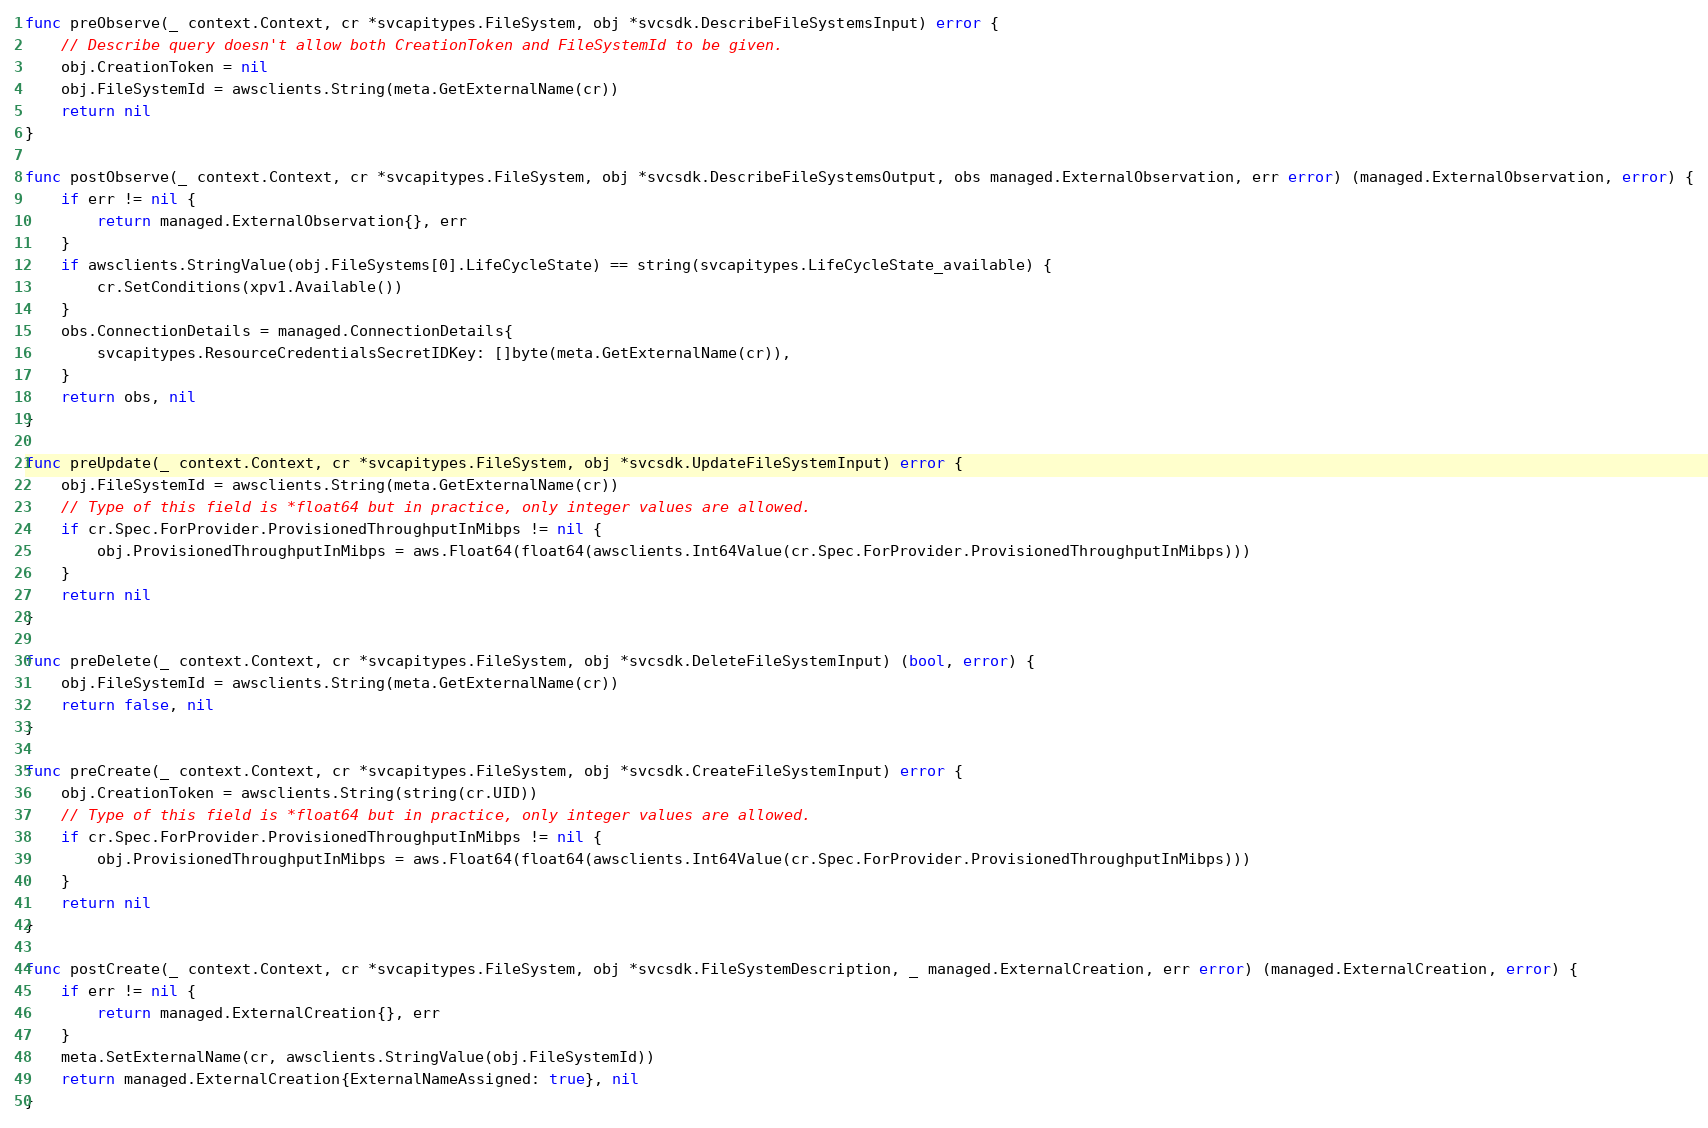Convert code to text. <code><loc_0><loc_0><loc_500><loc_500><_Go_>func preObserve(_ context.Context, cr *svcapitypes.FileSystem, obj *svcsdk.DescribeFileSystemsInput) error {
	// Describe query doesn't allow both CreationToken and FileSystemId to be given.
	obj.CreationToken = nil
	obj.FileSystemId = awsclients.String(meta.GetExternalName(cr))
	return nil
}

func postObserve(_ context.Context, cr *svcapitypes.FileSystem, obj *svcsdk.DescribeFileSystemsOutput, obs managed.ExternalObservation, err error) (managed.ExternalObservation, error) {
	if err != nil {
		return managed.ExternalObservation{}, err
	}
	if awsclients.StringValue(obj.FileSystems[0].LifeCycleState) == string(svcapitypes.LifeCycleState_available) {
		cr.SetConditions(xpv1.Available())
	}
	obs.ConnectionDetails = managed.ConnectionDetails{
		svcapitypes.ResourceCredentialsSecretIDKey: []byte(meta.GetExternalName(cr)),
	}
	return obs, nil
}

func preUpdate(_ context.Context, cr *svcapitypes.FileSystem, obj *svcsdk.UpdateFileSystemInput) error {
	obj.FileSystemId = awsclients.String(meta.GetExternalName(cr))
	// Type of this field is *float64 but in practice, only integer values are allowed.
	if cr.Spec.ForProvider.ProvisionedThroughputInMibps != nil {
		obj.ProvisionedThroughputInMibps = aws.Float64(float64(awsclients.Int64Value(cr.Spec.ForProvider.ProvisionedThroughputInMibps)))
	}
	return nil
}

func preDelete(_ context.Context, cr *svcapitypes.FileSystem, obj *svcsdk.DeleteFileSystemInput) (bool, error) {
	obj.FileSystemId = awsclients.String(meta.GetExternalName(cr))
	return false, nil
}

func preCreate(_ context.Context, cr *svcapitypes.FileSystem, obj *svcsdk.CreateFileSystemInput) error {
	obj.CreationToken = awsclients.String(string(cr.UID))
	// Type of this field is *float64 but in practice, only integer values are allowed.
	if cr.Spec.ForProvider.ProvisionedThroughputInMibps != nil {
		obj.ProvisionedThroughputInMibps = aws.Float64(float64(awsclients.Int64Value(cr.Spec.ForProvider.ProvisionedThroughputInMibps)))
	}
	return nil
}

func postCreate(_ context.Context, cr *svcapitypes.FileSystem, obj *svcsdk.FileSystemDescription, _ managed.ExternalCreation, err error) (managed.ExternalCreation, error) {
	if err != nil {
		return managed.ExternalCreation{}, err
	}
	meta.SetExternalName(cr, awsclients.StringValue(obj.FileSystemId))
	return managed.ExternalCreation{ExternalNameAssigned: true}, nil
}
</code> 